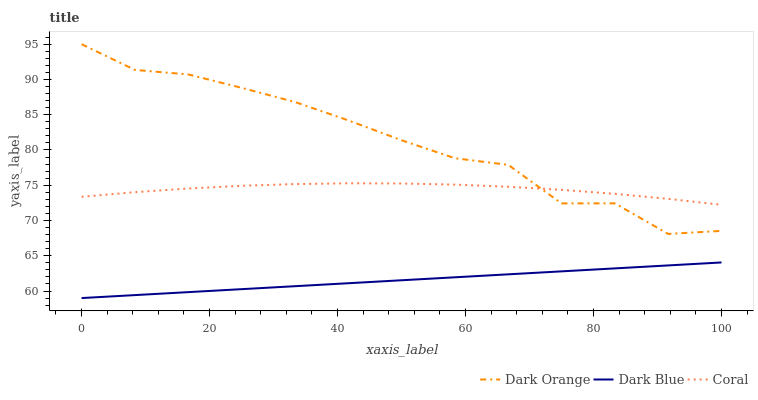Does Coral have the minimum area under the curve?
Answer yes or no. No. Does Coral have the maximum area under the curve?
Answer yes or no. No. Is Coral the smoothest?
Answer yes or no. No. Is Coral the roughest?
Answer yes or no. No. Does Coral have the lowest value?
Answer yes or no. No. Does Coral have the highest value?
Answer yes or no. No. Is Dark Blue less than Coral?
Answer yes or no. Yes. Is Dark Orange greater than Dark Blue?
Answer yes or no. Yes. Does Dark Blue intersect Coral?
Answer yes or no. No. 